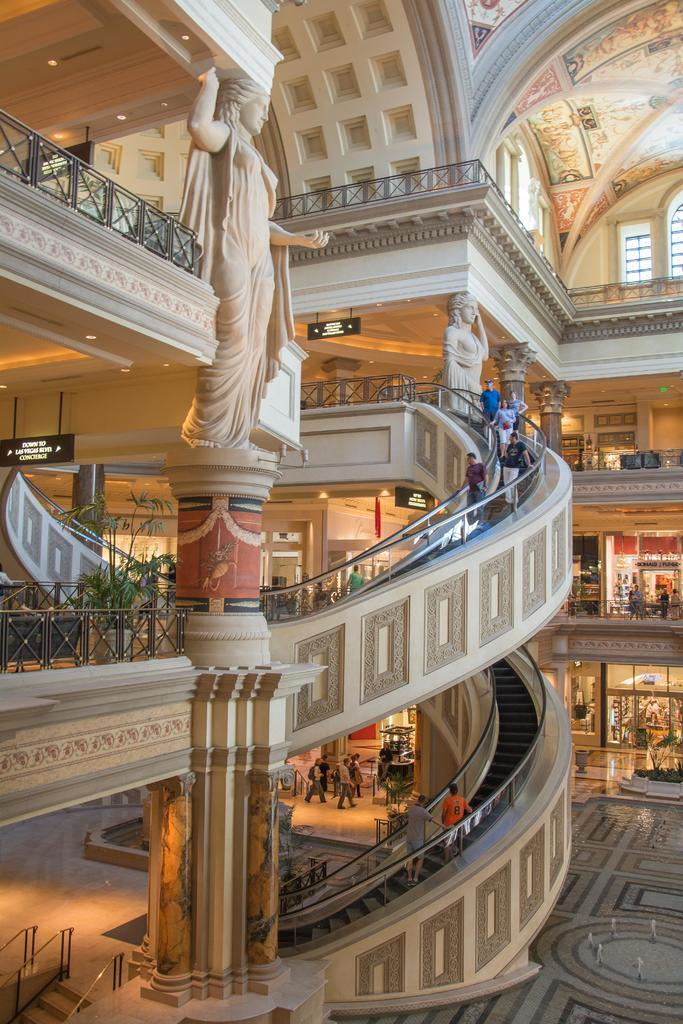What type of location is depicted in the image? The image shows the inside view of a building. What architectural features can be seen in the image? Escalators, pillars, railings, and ceilings are visible in the image. What decorative elements are present in the image? Statues and lights are visible in the image. What functional elements are present in the image? Boards and windows are present in the image. Are there any people in the image? Yes, people are visible in the image. How much profit does the tramp in the image generate for the building owner? There is no tramp present in the image, so it is not possible to determine any profit generated. 